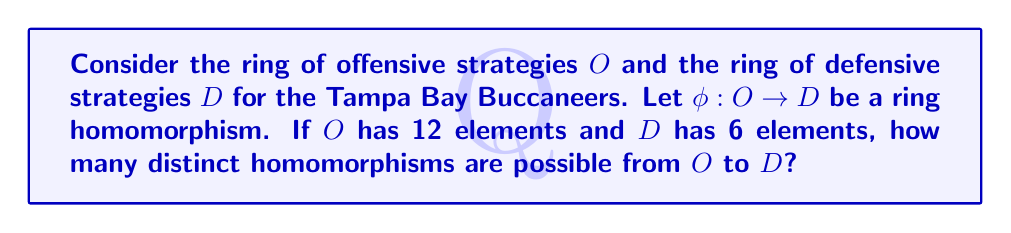Could you help me with this problem? To solve this problem, we need to apply the fundamental theorem of ring homomorphisms and consider the structure of finite rings. Let's break it down step-by-step:

1) In a ring homomorphism $\phi: O \rightarrow D$, the kernel of $\phi$ is a two-sided ideal of $O$.

2) The First Isomorphism Theorem states that $O/\ker(\phi) \cong \text{Im}(\phi)$.

3) Since $\text{Im}(\phi)$ is a subring of $D$, and $|D| = 6$, the possible orders for $\text{Im}(\phi)$ are 1, 2, 3, or 6 (the divisors of 6).

4) For each possible order of $\text{Im}(\phi)$, we need to determine how many subgroups of that order $D$ has:
   - Order 1: Only the trivial subgroup
   - Order 2: One subgroup (since 6/2 = 3, which is prime)
   - Order 3: One subgroup (since 6/3 = 2, which is prime)
   - Order 6: Only $D$ itself

5) Now, for each possible $\text{Im}(\phi)$, we need to count the number of homomorphisms:
   - If $|\text{Im}(\phi)| = 1$, there is only one homomorphism (the trivial one).
   - If $|\text{Im}(\phi)| = 2$, there is one homomorphism (mapping to the unique subgroup of order 2).
   - If $|\text{Im}(\phi)| = 3$, there is one homomorphism (mapping to the unique subgroup of order 3).
   - If $|\text{Im}(\phi)| = 6$, we need to count isomorphisms from $O$ to $D$. 
     However, since $|O| = 12$ and $|D| = 6$, there are no isomorphisms between them.

6) Therefore, the total number of distinct homomorphisms is 1 + 1 + 1 = 3.

This analysis shows how the structure of offensive and defensive strategies can be mapped between each other, with limited possibilities due to their different sizes.
Answer: There are 3 distinct homomorphisms possible from $O$ to $D$. 